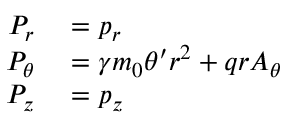<formula> <loc_0><loc_0><loc_500><loc_500>\begin{array} { r l } { P _ { r } } & = p _ { r } } \\ { P _ { \theta } } & = \gamma m _ { 0 } \theta ^ { \prime } r ^ { 2 } + q r A _ { \theta } } \\ { P _ { z } } & = p _ { z } } \end{array}</formula> 